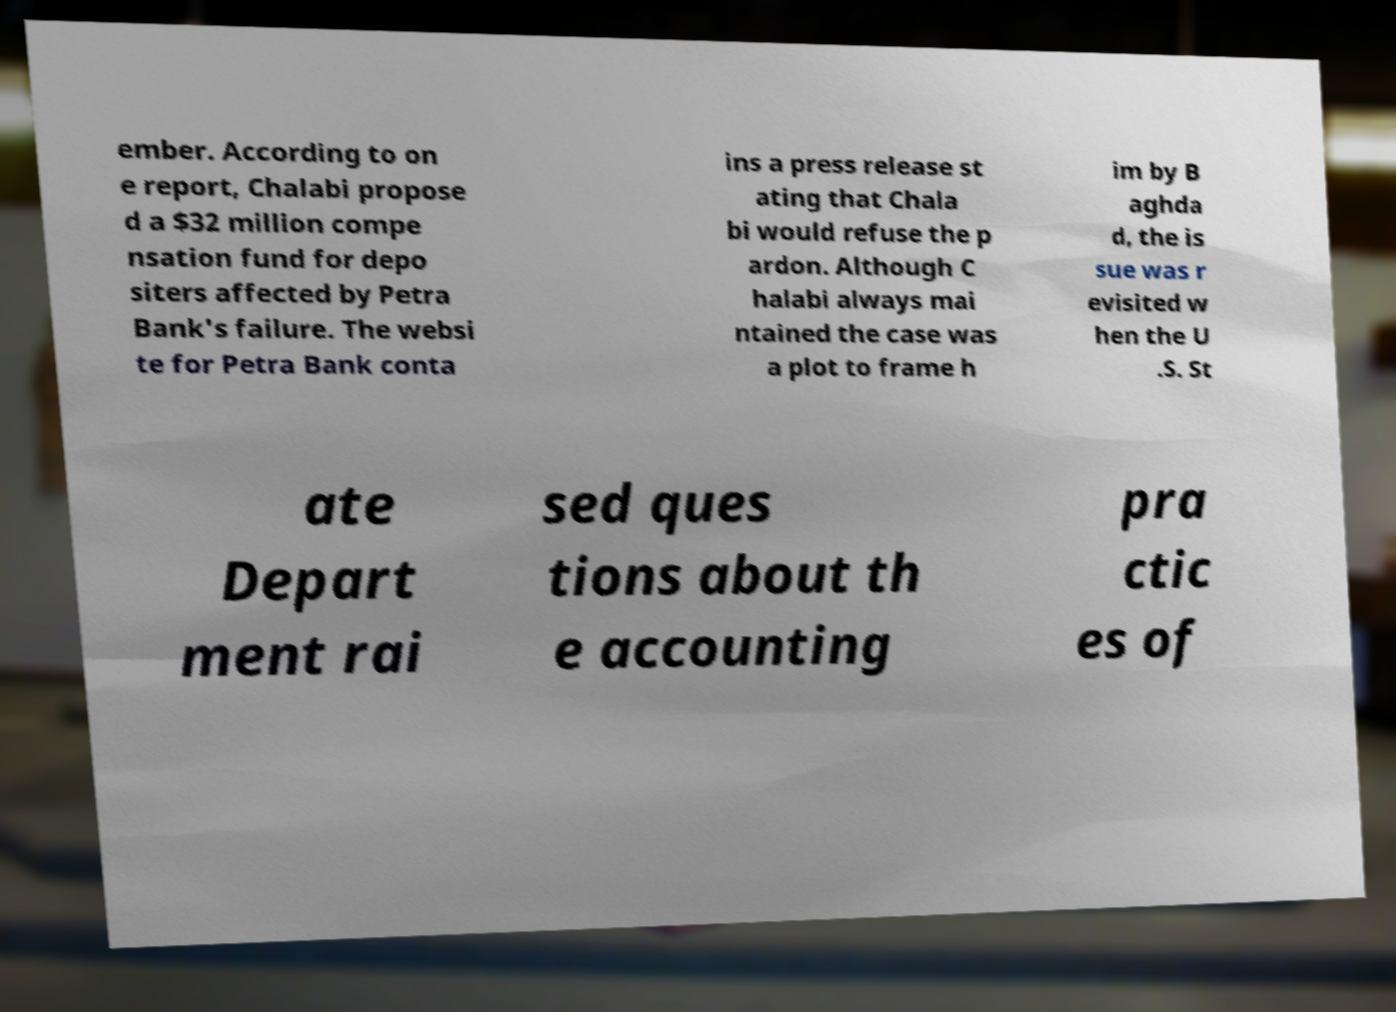I need the written content from this picture converted into text. Can you do that? ember. According to on e report, Chalabi propose d a $32 million compe nsation fund for depo siters affected by Petra Bank's failure. The websi te for Petra Bank conta ins a press release st ating that Chala bi would refuse the p ardon. Although C halabi always mai ntained the case was a plot to frame h im by B aghda d, the is sue was r evisited w hen the U .S. St ate Depart ment rai sed ques tions about th e accounting pra ctic es of 